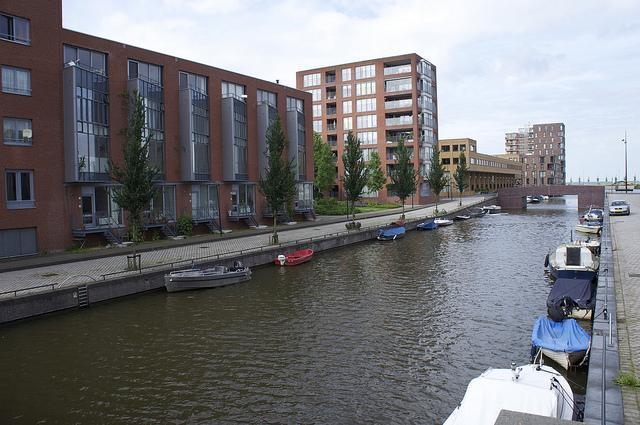How many cars are parked next to the canal?
Give a very brief answer. 1. How many boats are visible?
Give a very brief answer. 2. 